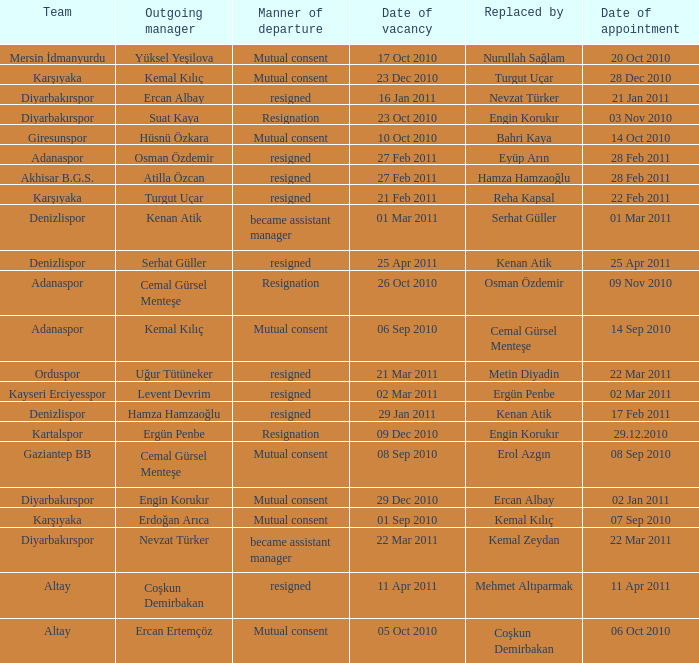Who replaced the manager of Akhisar B.G.S.? Hamza Hamzaoğlu. 